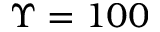Convert formula to latex. <formula><loc_0><loc_0><loc_500><loc_500>\Upsilon = 1 0 0</formula> 